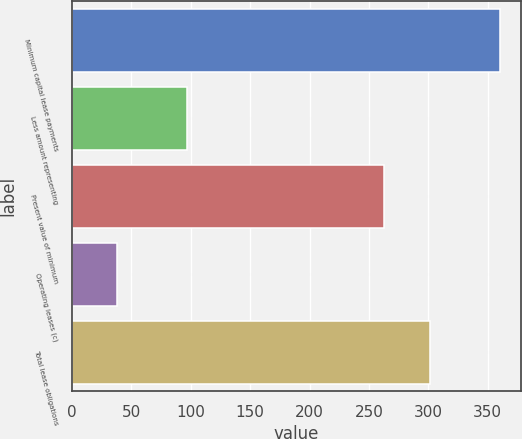Convert chart to OTSL. <chart><loc_0><loc_0><loc_500><loc_500><bar_chart><fcel>Minimum capital lease payments<fcel>Less amount representing<fcel>Present value of minimum<fcel>Operating leases (c)<fcel>Total lease obligations<nl><fcel>360<fcel>97<fcel>263<fcel>38<fcel>301<nl></chart> 